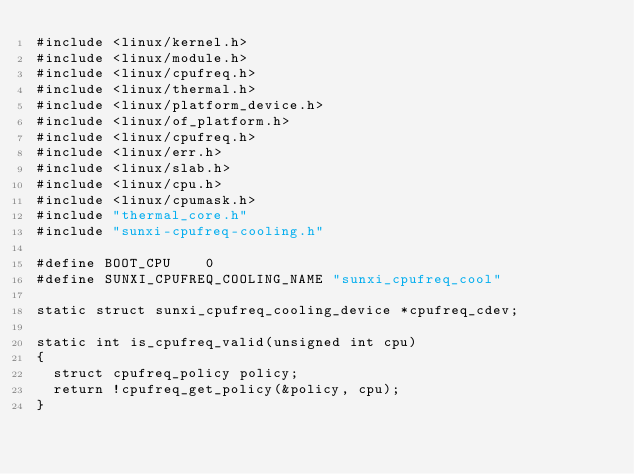Convert code to text. <code><loc_0><loc_0><loc_500><loc_500><_C_>#include <linux/kernel.h>
#include <linux/module.h>
#include <linux/cpufreq.h>
#include <linux/thermal.h>
#include <linux/platform_device.h>
#include <linux/of_platform.h>
#include <linux/cpufreq.h>
#include <linux/err.h>
#include <linux/slab.h>
#include <linux/cpu.h>
#include <linux/cpumask.h>
#include "thermal_core.h"
#include "sunxi-cpufreq-cooling.h"

#define BOOT_CPU    0
#define SUNXI_CPUFREQ_COOLING_NAME "sunxi_cpufreq_cool"

static struct sunxi_cpufreq_cooling_device *cpufreq_cdev;

static int is_cpufreq_valid(unsigned int cpu)
{
	struct cpufreq_policy policy;
	return !cpufreq_get_policy(&policy, cpu);
}
</code> 